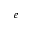Convert formula to latex. <formula><loc_0><loc_0><loc_500><loc_500>_ { e }</formula> 